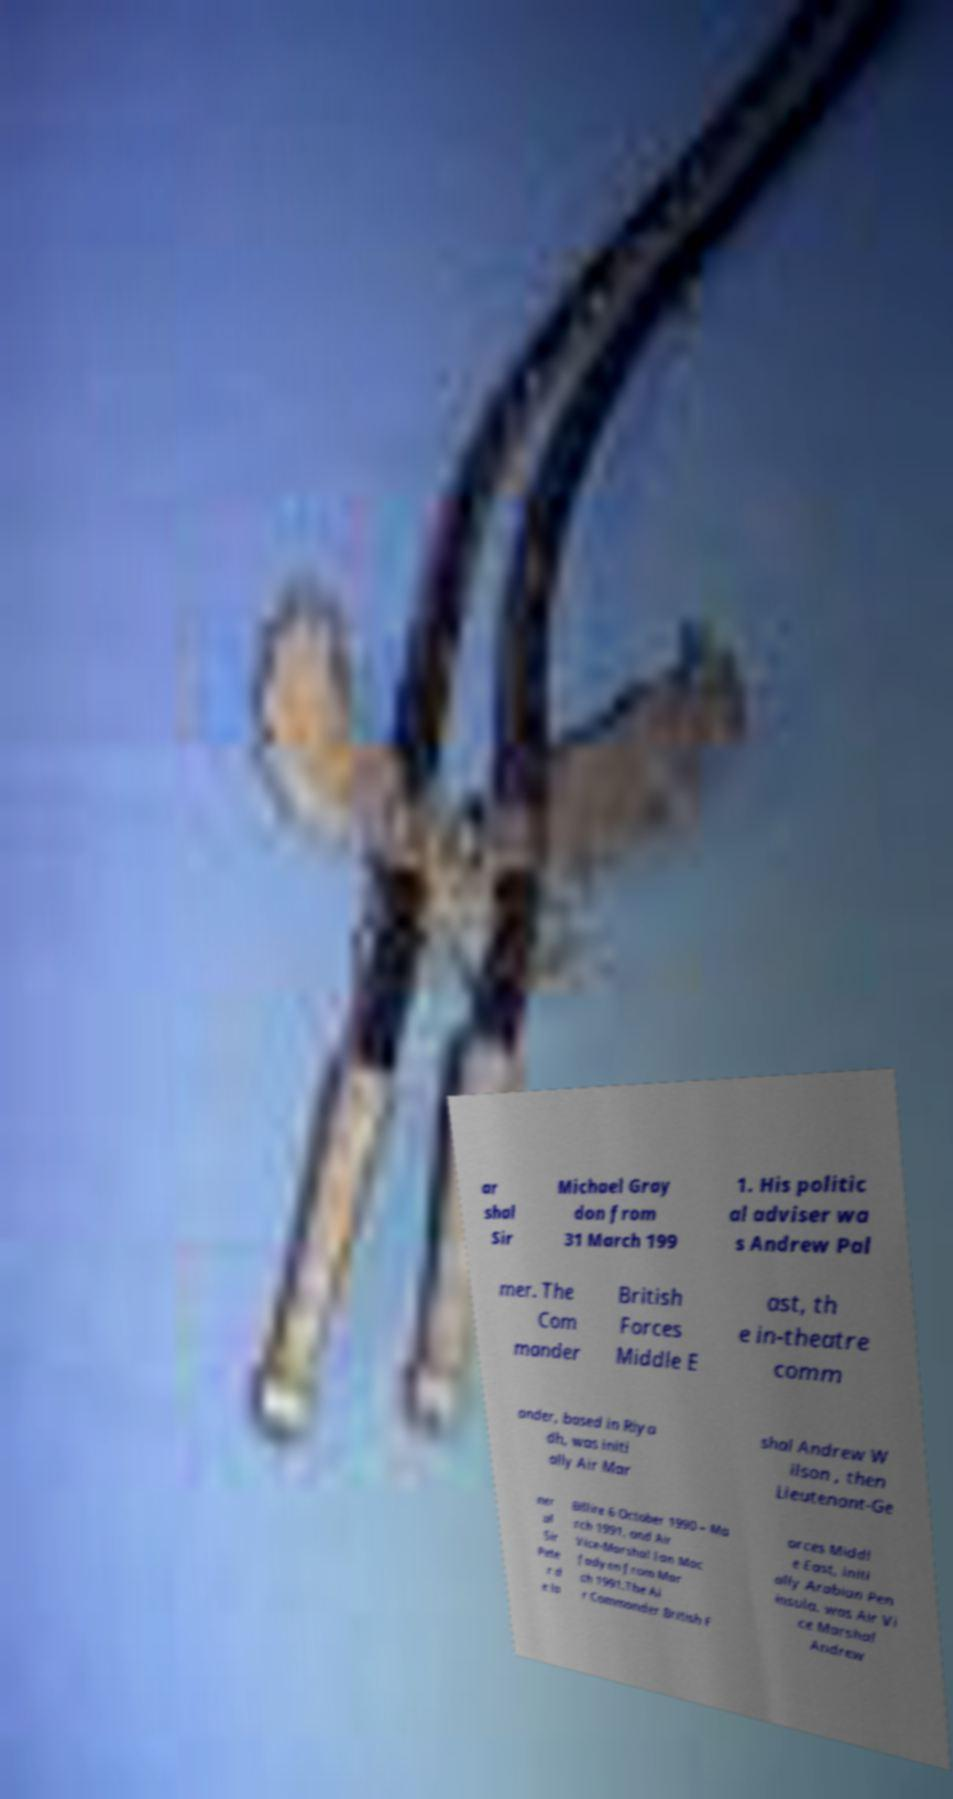I need the written content from this picture converted into text. Can you do that? ar shal Sir Michael Gray don from 31 March 199 1. His politic al adviser wa s Andrew Pal mer. The Com mander British Forces Middle E ast, th e in-theatre comm ander, based in Riya dh, was initi ally Air Mar shal Andrew W ilson , then Lieutenant-Ge ner al Sir Pete r d e la Billire 6 October 1990 – Ma rch 1991, and Air Vice-Marshal Ian Mac fadyen from Mar ch 1991.The Ai r Commander British F orces Middl e East, initi ally Arabian Pen insula, was Air Vi ce Marshal Andrew 